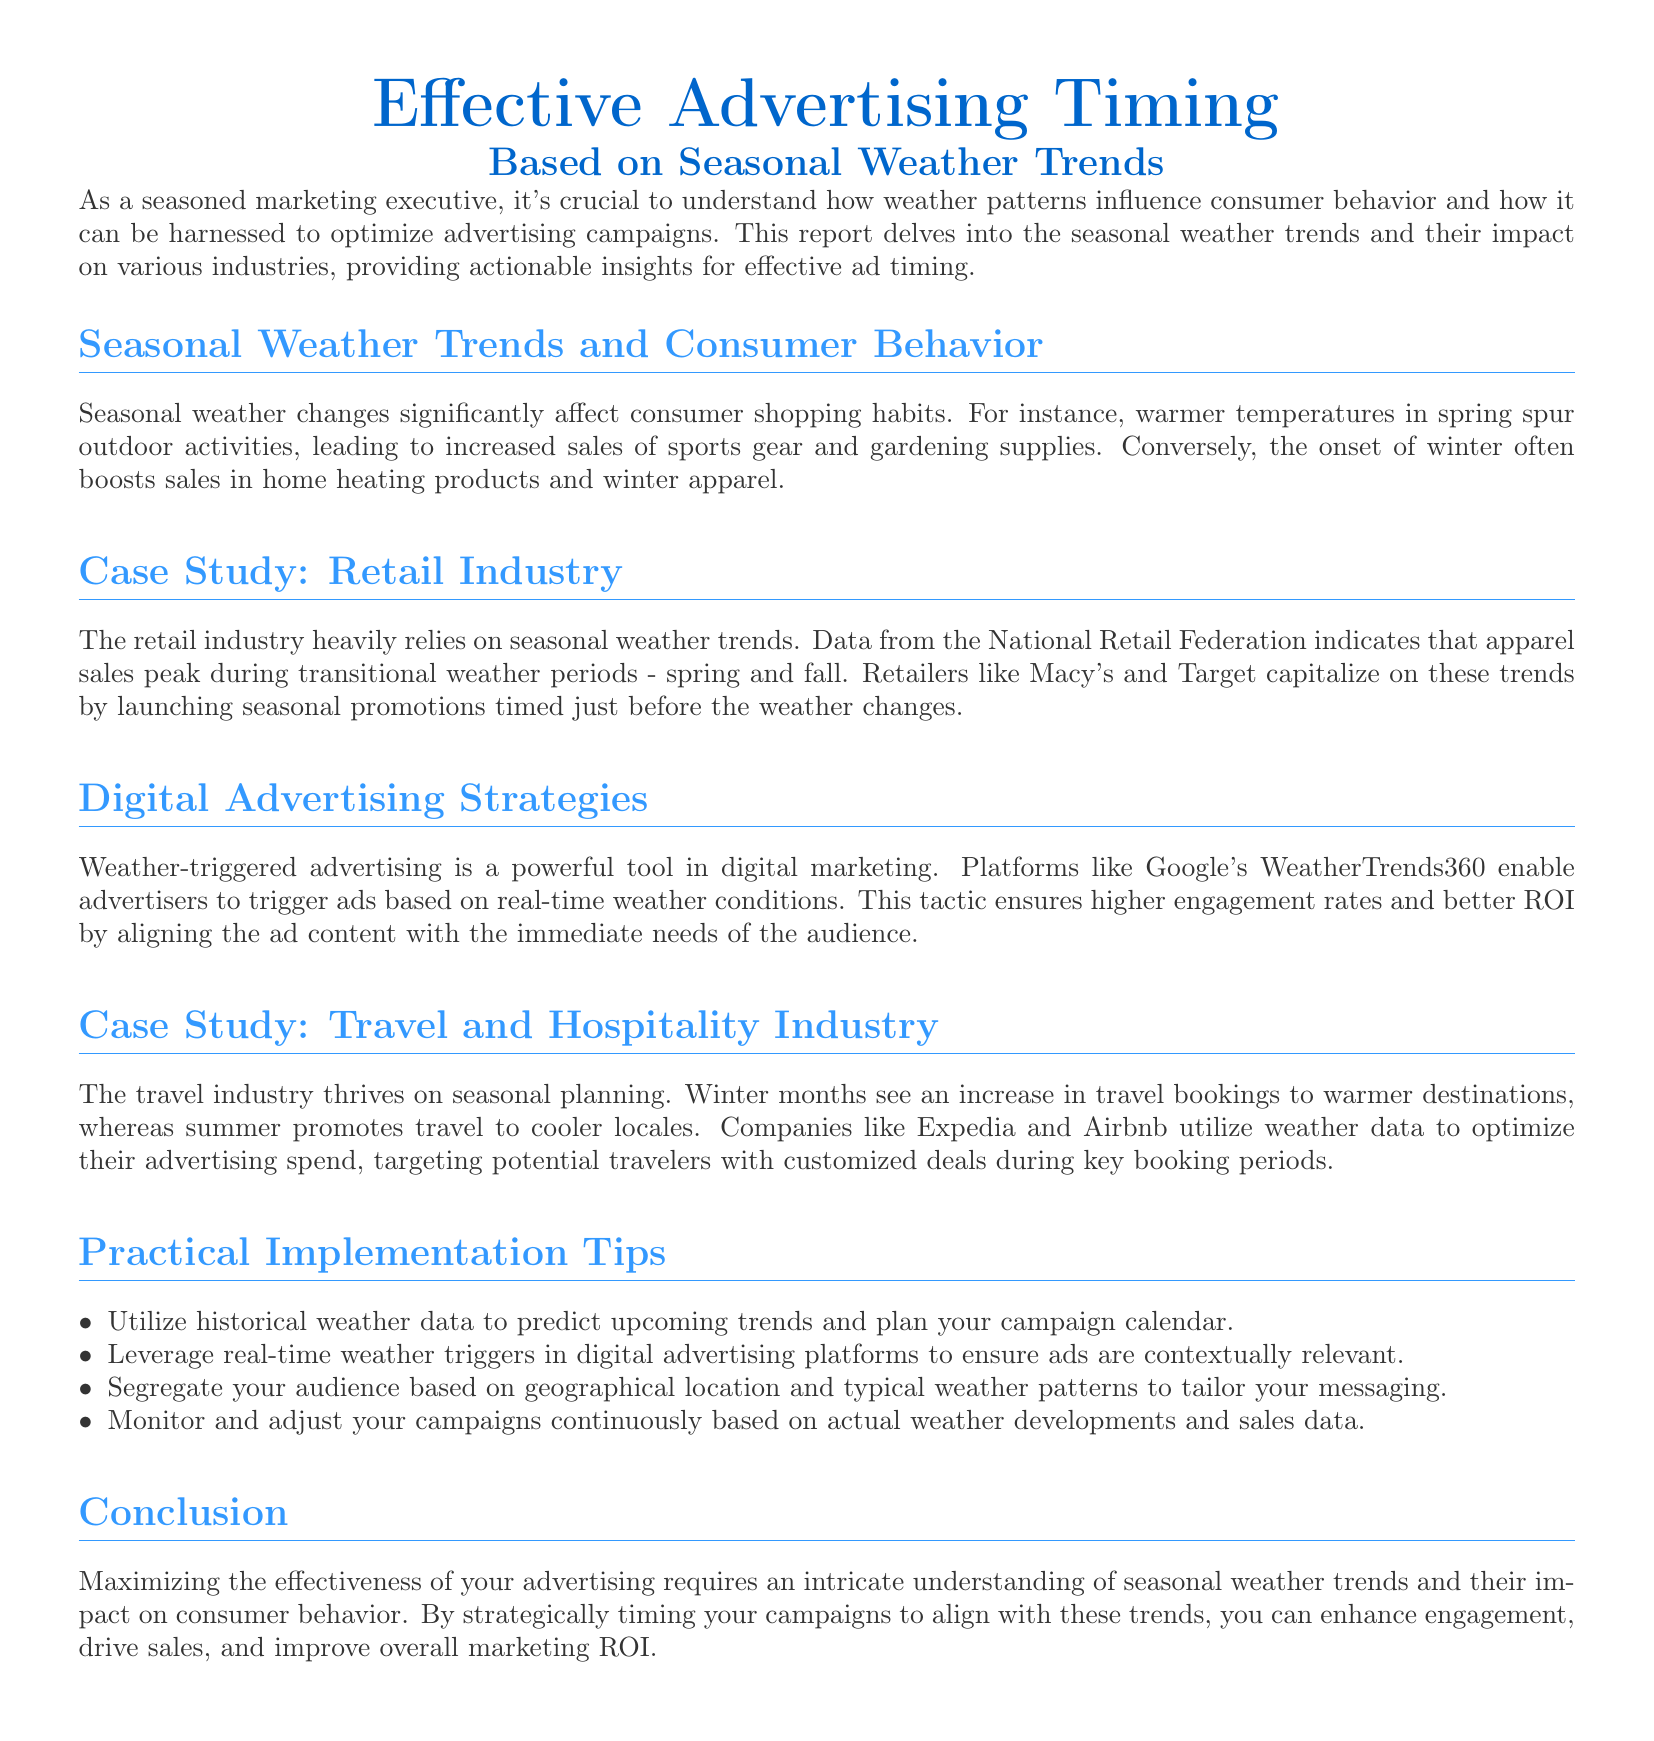What is the title of the report? The title of the report provided at the beginning of the document is "Effective Advertising Timing Based on Seasonal Weather Trends."
Answer: Effective Advertising Timing Based on Seasonal Weather Trends Which industry relies heavily on seasonal weather trends according to the report? The document mentions that the retail industry relies heavily on seasonal weather trends.
Answer: Retail industry What do warmer temperatures in spring increase the sales of? The document states that warmer temperatures in spring lead to increased sales of sports gear and gardening supplies.
Answer: Sports gear and gardening supplies Which companies utilize weather data for advertising in the travel industry? According to the report, companies like Expedia and Airbnb utilize weather data to optimize their advertising spend.
Answer: Expedia and Airbnb What is one recommended practical implementation tip? The document lists several tips, one of which is to utilize historical weather data to predict upcoming trends and plan your campaign calendar.
Answer: Utilize historical weather data How do retailers like Macy's and Target time their promotions? The document indicates that retailers like Macy's and Target launch seasonal promotions timed just before the weather changes.
Answer: Just before the weather changes What is the expected effect of weather-triggered advertising according to the document? The report suggests that weather-triggered advertising leads to higher engagement rates and better ROI.
Answer: Higher engagement rates and better ROI In which months do winter travel bookings typically increase? The document mentions that winter months see an increase in travel bookings to warmer destinations.
Answer: Winter months What should marketers monitor continuously as per the practical tips? The report advises that marketers should monitor and adjust their campaigns continuously based on actual weather developments and sales data.
Answer: Actual weather developments and sales data 